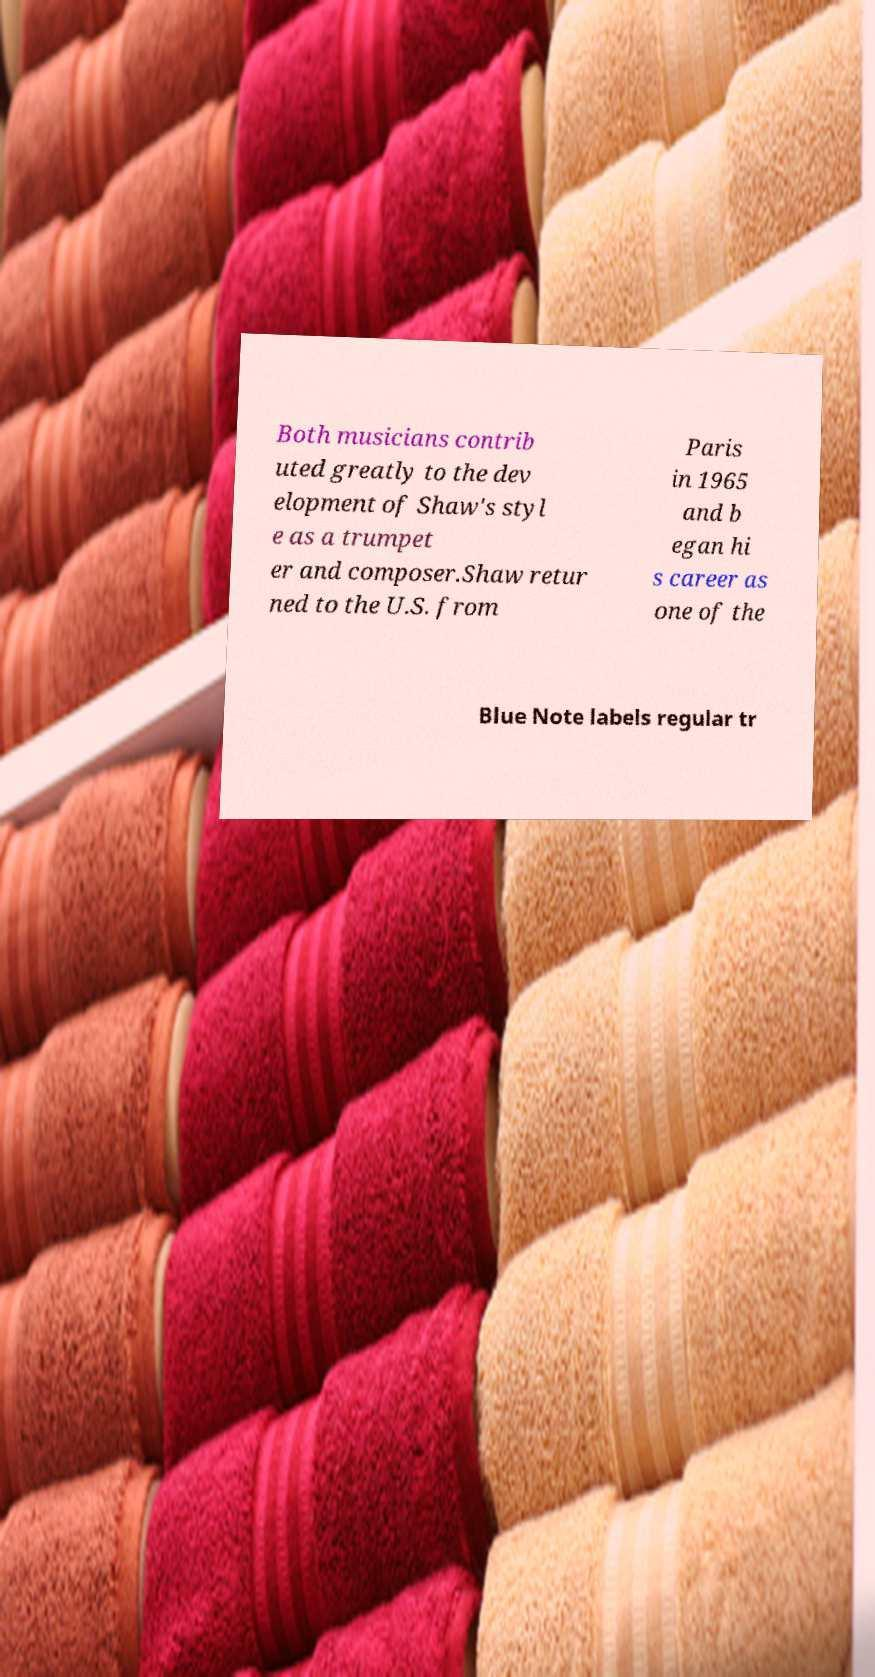Please read and relay the text visible in this image. What does it say? Both musicians contrib uted greatly to the dev elopment of Shaw's styl e as a trumpet er and composer.Shaw retur ned to the U.S. from Paris in 1965 and b egan hi s career as one of the Blue Note labels regular tr 